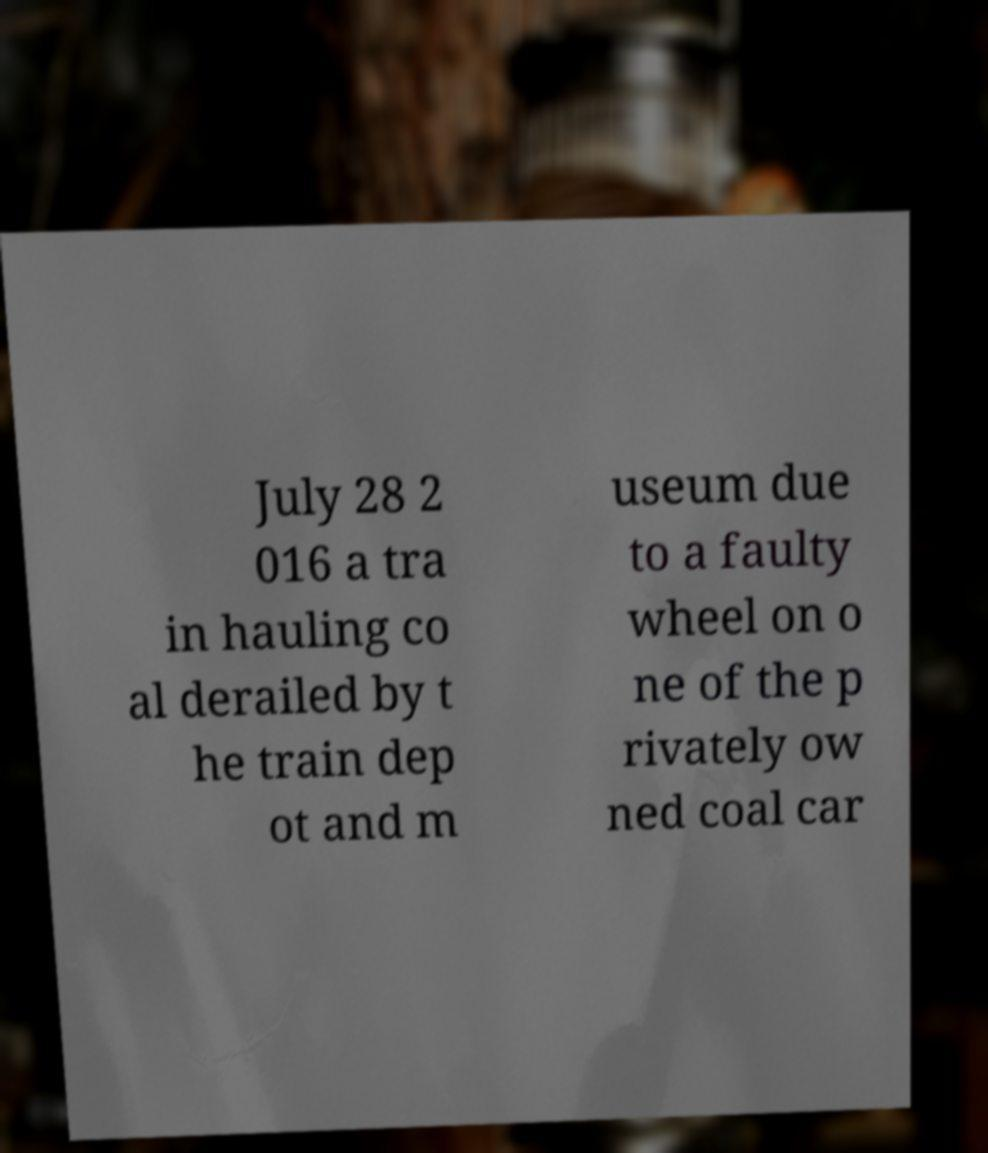I need the written content from this picture converted into text. Can you do that? July 28 2 016 a tra in hauling co al derailed by t he train dep ot and m useum due to a faulty wheel on o ne of the p rivately ow ned coal car 